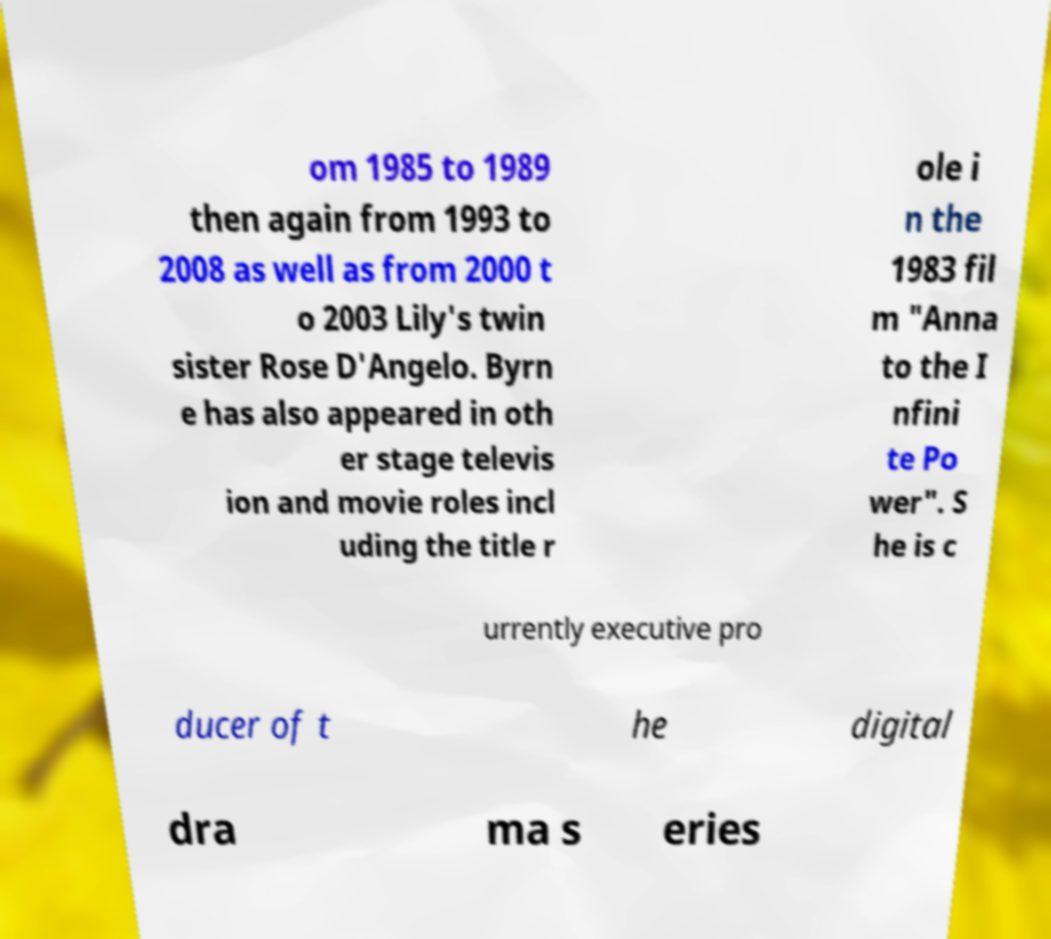Can you accurately transcribe the text from the provided image for me? om 1985 to 1989 then again from 1993 to 2008 as well as from 2000 t o 2003 Lily's twin sister Rose D'Angelo. Byrn e has also appeared in oth er stage televis ion and movie roles incl uding the title r ole i n the 1983 fil m "Anna to the I nfini te Po wer". S he is c urrently executive pro ducer of t he digital dra ma s eries 